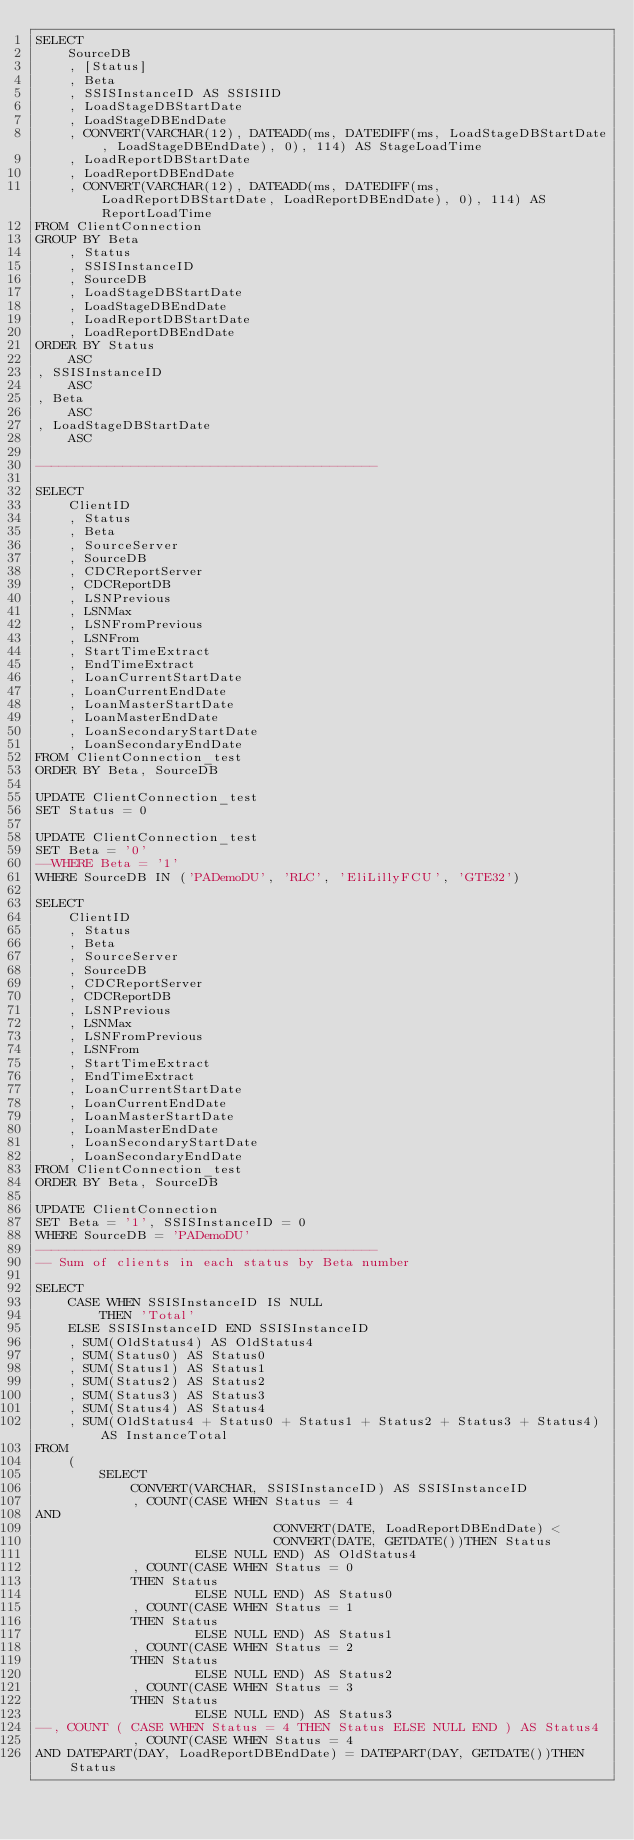Convert code to text. <code><loc_0><loc_0><loc_500><loc_500><_SQL_>SELECT
    SourceDB
    , [Status]
    , Beta
    , SSISInstanceID AS SSISIID
    , LoadStageDBStartDate
    , LoadStageDBEndDate
    , CONVERT(VARCHAR(12), DATEADD(ms, DATEDIFF(ms, LoadStageDBStartDate, LoadStageDBEndDate), 0), 114) AS StageLoadTime
    , LoadReportDBStartDate
    , LoadReportDBEndDate
    , CONVERT(VARCHAR(12), DATEADD(ms, DATEDIFF(ms, LoadReportDBStartDate, LoadReportDBEndDate), 0), 114) AS ReportLoadTime
FROM ClientConnection
GROUP BY Beta
    , Status
    , SSISInstanceID
    , SourceDB
    , LoadStageDBStartDate
    , LoadStageDBEndDate
    , LoadReportDBStartDate
    , LoadReportDBEndDate
ORDER BY Status
    ASC
, SSISInstanceID
    ASC
, Beta
    ASC
, LoadStageDBStartDate
    ASC

-------------------------------------------

SELECT
    ClientID
    , Status
    , Beta
    , SourceServer
    , SourceDB
    , CDCReportServer
    , CDCReportDB
    , LSNPrevious
    , LSNMax
    , LSNFromPrevious
    , LSNFrom
    , StartTimeExtract
    , EndTimeExtract
    , LoanCurrentStartDate
    , LoanCurrentEndDate
    , LoanMasterStartDate
    , LoanMasterEndDate
    , LoanSecondaryStartDate
    , LoanSecondaryEndDate
FROM ClientConnection_test
ORDER BY Beta, SourceDB

UPDATE ClientConnection_test
SET Status = 0

UPDATE ClientConnection_test
SET Beta = '0'
--WHERE Beta = '1'
WHERE SourceDB IN ('PADemoDU', 'RLC', 'EliLillyFCU', 'GTE32')

SELECT
    ClientID
    , Status
    , Beta
    , SourceServer
    , SourceDB
    , CDCReportServer
    , CDCReportDB
    , LSNPrevious
    , LSNMax
    , LSNFromPrevious
    , LSNFrom
    , StartTimeExtract
    , EndTimeExtract
    , LoanCurrentStartDate
    , LoanCurrentEndDate
    , LoanMasterStartDate
    , LoanMasterEndDate
    , LoanSecondaryStartDate
    , LoanSecondaryEndDate
FROM ClientConnection_test
ORDER BY Beta, SourceDB

UPDATE ClientConnection
SET Beta = '1', SSISInstanceID = 0
WHERE SourceDB = 'PADemoDU'
-------------------------------------------
-- Sum of clients in each status by Beta number

SELECT
    CASE WHEN SSISInstanceID IS NULL
        THEN 'Total'
    ELSE SSISInstanceID END SSISInstanceID
    , SUM(OldStatus4) AS OldStatus4
    , SUM(Status0) AS Status0
    , SUM(Status1) AS Status1
    , SUM(Status2) AS Status2
    , SUM(Status3) AS Status3
    , SUM(Status4) AS Status4
    , SUM(OldStatus4 + Status0 + Status1 + Status2 + Status3 + Status4) AS InstanceTotal
FROM
    (
        SELECT
            CONVERT(VARCHAR, SSISInstanceID) AS SSISInstanceID
            , COUNT(CASE WHEN Status = 4
AND
                              CONVERT(DATE, LoadReportDBEndDate) <
                              CONVERT(DATE, GETDATE())THEN Status
                    ELSE NULL END) AS OldStatus4
            , COUNT(CASE WHEN Status = 0
            THEN Status
                    ELSE NULL END) AS Status0
            , COUNT(CASE WHEN Status = 1
            THEN Status
                    ELSE NULL END) AS Status1
            , COUNT(CASE WHEN Status = 2
            THEN Status
                    ELSE NULL END) AS Status2
            , COUNT(CASE WHEN Status = 3
            THEN Status
                    ELSE NULL END) AS Status3
--, COUNT ( CASE WHEN Status = 4 THEN Status ELSE NULL END ) AS Status4
            , COUNT(CASE WHEN Status = 4
AND DATEPART(DAY, LoadReportDBEndDate) = DATEPART(DAY, GETDATE())THEN Status</code> 